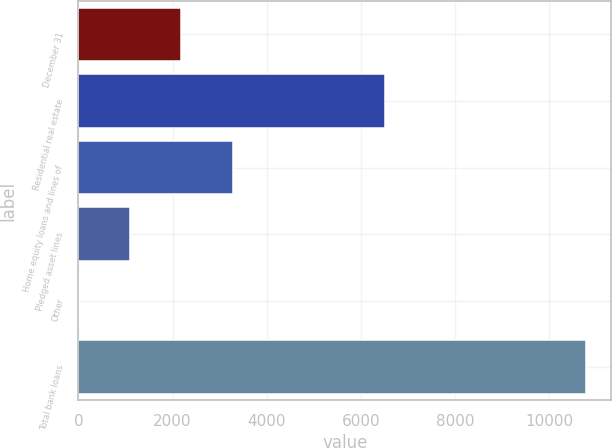Convert chart. <chart><loc_0><loc_0><loc_500><loc_500><bar_chart><fcel>December 31<fcel>Residential real estate<fcel>Home equity loans and lines of<fcel>Pledged asset lines<fcel>Other<fcel>Total bank loans<nl><fcel>2173.4<fcel>6507<fcel>3287<fcel>1097.7<fcel>22<fcel>10779<nl></chart> 